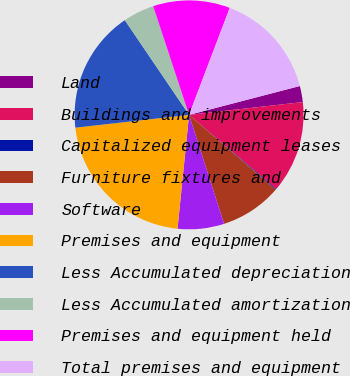<chart> <loc_0><loc_0><loc_500><loc_500><pie_chart><fcel>Land<fcel>Buildings and improvements<fcel>Capitalized equipment leases<fcel>Furniture fixtures and<fcel>Software<fcel>Premises and equipment<fcel>Less Accumulated depreciation<fcel>Less Accumulated amortization<fcel>Premises and equipment held<fcel>Total premises and equipment<nl><fcel>2.27%<fcel>13.01%<fcel>0.12%<fcel>8.71%<fcel>6.56%<fcel>21.6%<fcel>17.3%<fcel>4.41%<fcel>10.86%<fcel>15.16%<nl></chart> 